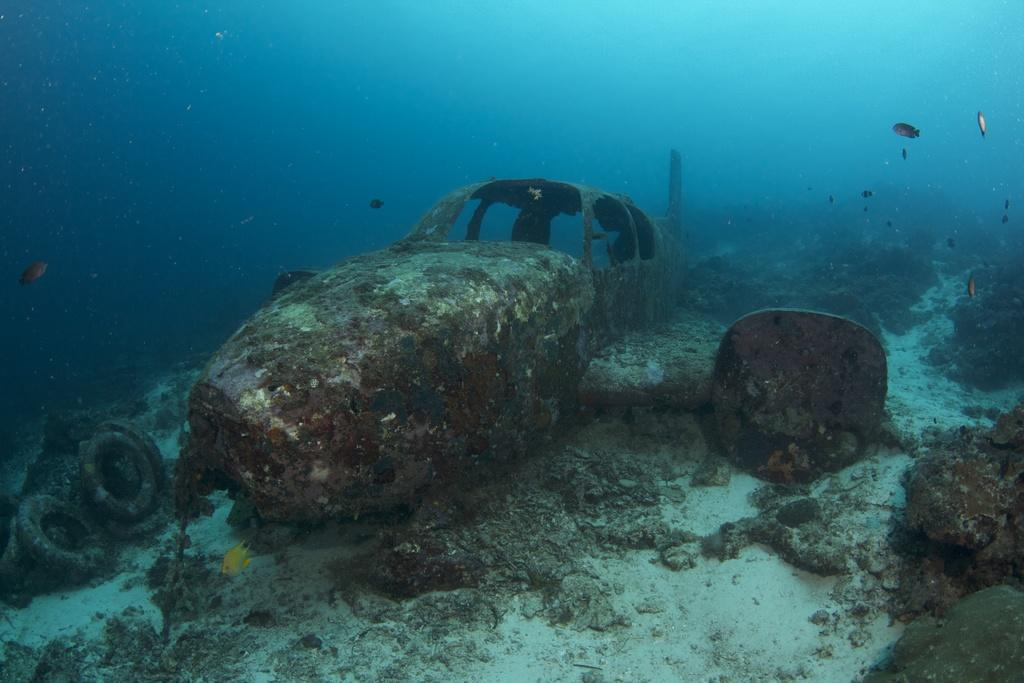What is the setting of the image? The image is underwater. What type of marine life can be seen in the image? There are fishes in the image. What man-made object is present in the image? There is a crashed plane with a rusted body in the image. Are there any other objects visible in the water? Yes, there are other objects in the water in the image. What type of fang can be seen in the image? There is no fang present in the image; it is set underwater with fishes and a crashed plane. What type of rice is being served in the image? There is no rice present in the image; it is set underwater with fishes and a crashed plane. 